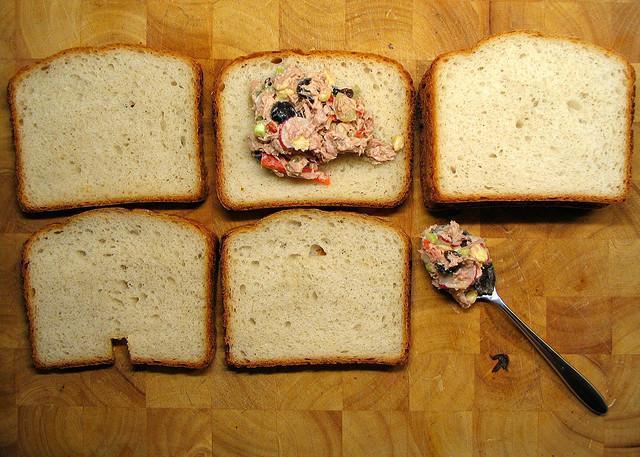How many slices of bread will filling be put on?
From the following set of four choices, select the accurate answer to respond to the question.
Options: Two, four, three, six. Three. 